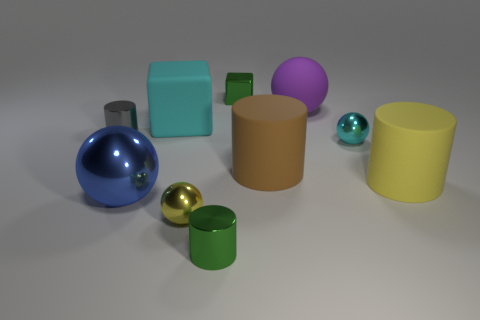Are there any tiny rubber objects?
Offer a very short reply. No. What number of tiny objects are brown cylinders or green matte cylinders?
Offer a very short reply. 0. Is there anything else of the same color as the large metallic object?
Keep it short and to the point. No. What is the shape of the small cyan object that is the same material as the small green block?
Offer a terse response. Sphere. There is a yellow thing that is in front of the big yellow cylinder; what size is it?
Your answer should be very brief. Small. The small cyan shiny thing has what shape?
Your answer should be very brief. Sphere. Does the green object to the right of the tiny green metallic cylinder have the same size as the metal cylinder that is in front of the gray cylinder?
Offer a very short reply. Yes. There is a metal cylinder that is in front of the large cylinder to the right of the matte cylinder to the left of the tiny cyan metal sphere; what size is it?
Your answer should be compact. Small. There is a tiny green shiny object in front of the block on the left side of the metal cylinder in front of the gray shiny cylinder; what is its shape?
Keep it short and to the point. Cylinder. There is a rubber thing that is on the left side of the yellow shiny object; what is its shape?
Keep it short and to the point. Cube. 